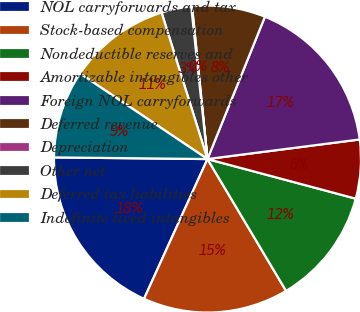<chart> <loc_0><loc_0><loc_500><loc_500><pie_chart><fcel>NOL carryforwards and tax<fcel>Stock-based compensation<fcel>Nondeductible reserves and<fcel>Amortizable intangibles other<fcel>Foreign NOL carryforwards<fcel>Deferred revenue<fcel>Depreciation<fcel>Other net<fcel>Deferred tax liabilities<fcel>Indefinite lived intangibles<nl><fcel>18.39%<fcel>15.34%<fcel>12.29%<fcel>6.19%<fcel>16.86%<fcel>7.71%<fcel>0.09%<fcel>3.14%<fcel>10.76%<fcel>9.24%<nl></chart> 